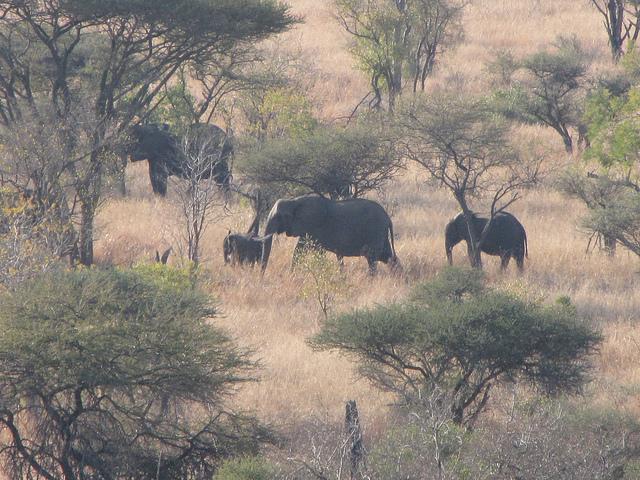Where are the animals going?
Short answer required. Water. Are there any animals shown that appear younger than most others?
Keep it brief. Yes. What kind of trees are these?
Be succinct. Acacia. Is this grass green?
Keep it brief. No. 